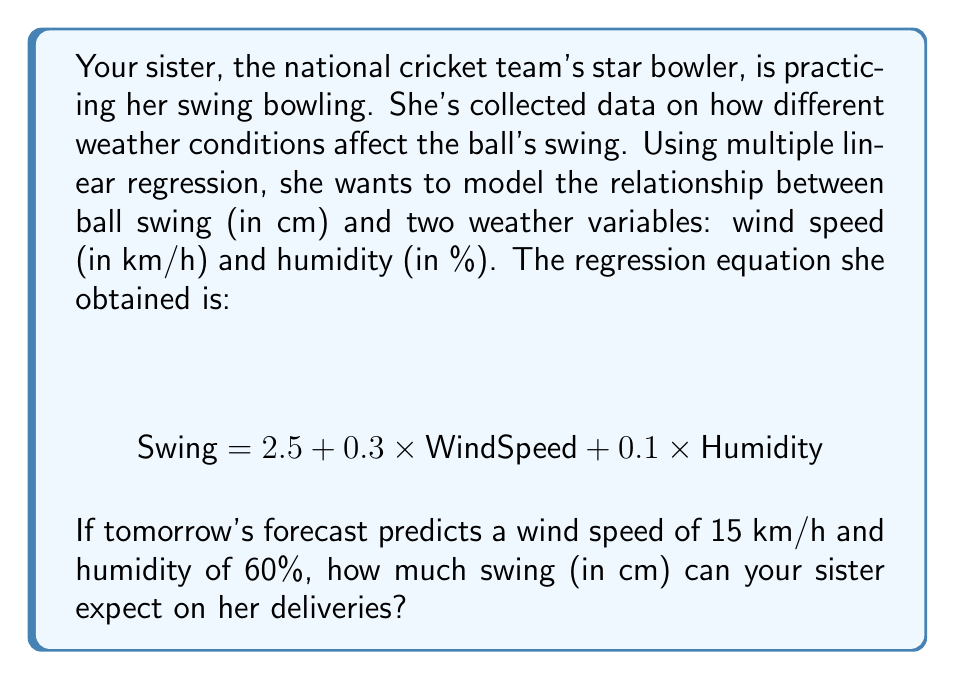Provide a solution to this math problem. Let's approach this step-by-step:

1) We're given the multiple linear regression equation:
   $$ \text{Swing} = 2.5 + 0.3 \times \text{WindSpeed} + 0.1 \times \text{Humidity} $$

2) We need to substitute the given values into this equation:
   - Wind Speed = 15 km/h
   - Humidity = 60%

3) Let's substitute these values:
   $$ \text{Swing} = 2.5 + 0.3 \times 15 + 0.1 \times 60 $$

4) Now, let's solve this equation step by step:
   $$ \text{Swing} = 2.5 + 4.5 + 6 $$

5) Adding these numbers:
   $$ \text{Swing} = 13 $$

Therefore, under these weather conditions, your sister can expect a swing of 13 cm on her deliveries.
Answer: 13 cm 